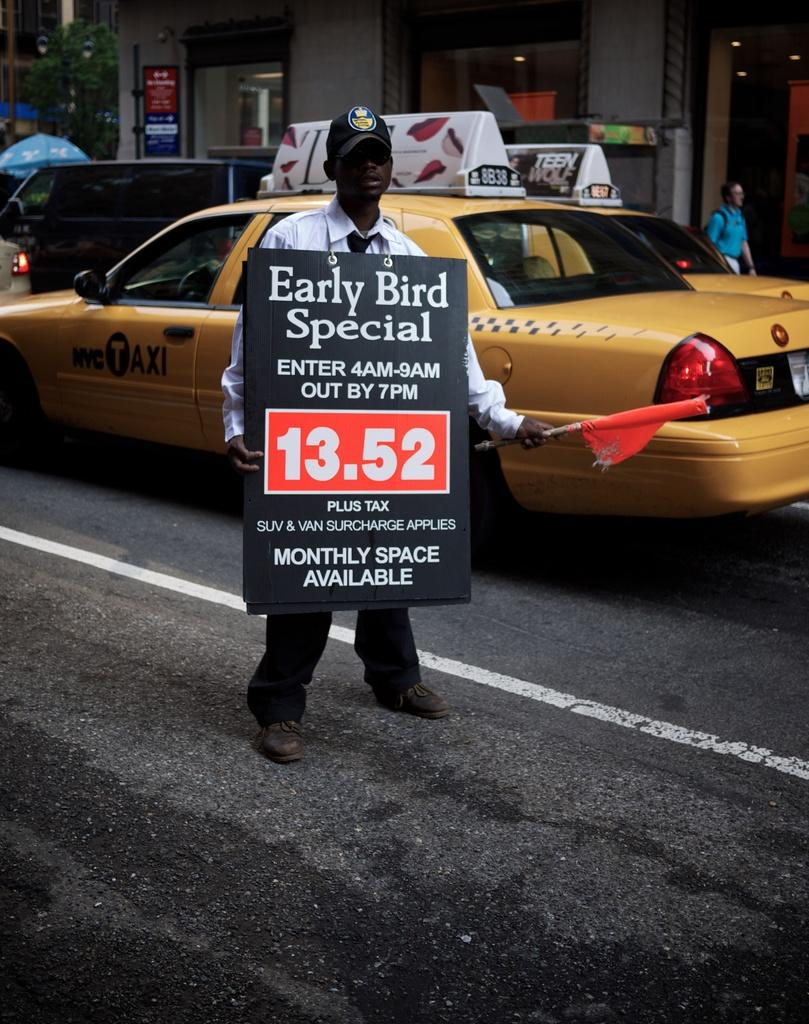<image>
Describe the image concisely. a sign that has 13.52 on it in the day 